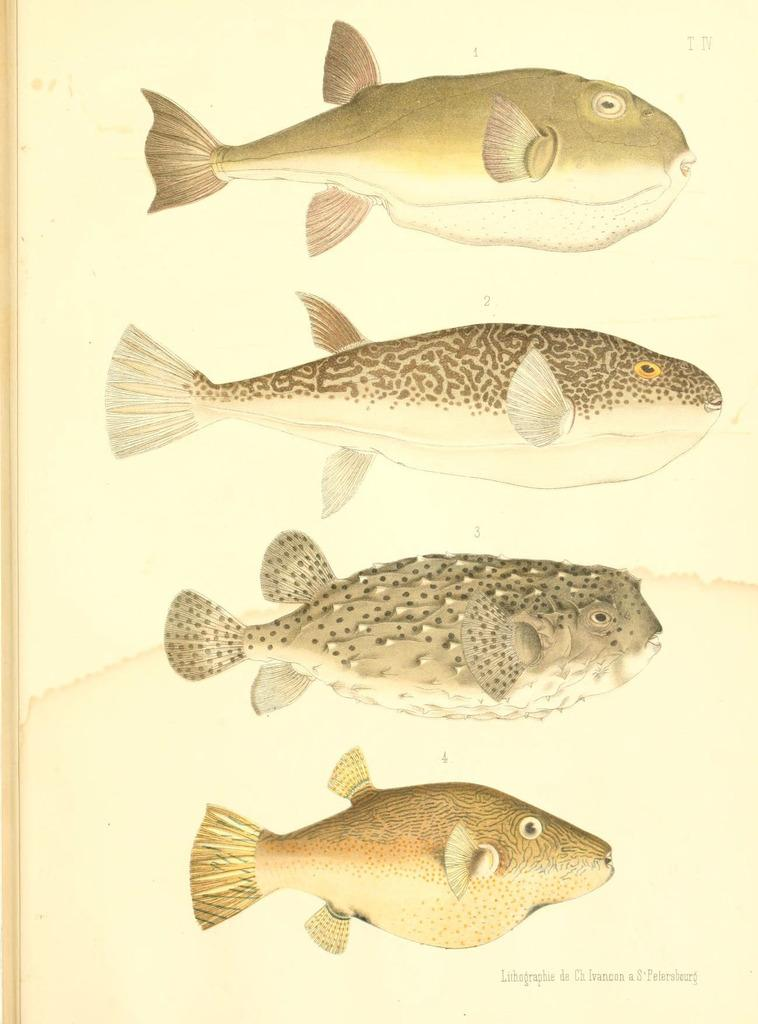What is depicted in the image? There is a drawing in the image. What is the subject matter of the drawing? The drawing features four different types of fishes. On what surface is the drawing made? The drawing is on a paper. What time does the clock in the drawing show? There is no clock present in the drawing; it features four different types of fishes. 